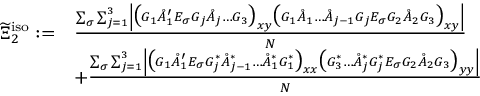Convert formula to latex. <formula><loc_0><loc_0><loc_500><loc_500>\begin{array} { r l } { \widetilde { \Xi } _ { 2 } ^ { i s o } \colon = } & { \frac { \sum _ { \sigma } \sum _ { j = 1 } ^ { 3 } \left | \left ( G _ { 1 } \mathring { A } _ { 1 } ^ { \prime } E _ { \sigma } G _ { j } \mathring { A } _ { j } \dots G _ { 3 } \right ) _ { x y } \left ( G _ { 1 } \mathring { A } _ { 1 } \dots \mathring { A } _ { j - 1 } G _ { j } E _ { \sigma } G _ { 2 } \mathring { A } _ { 2 } G _ { 3 } \right ) _ { x y } \right | } { N } } \\ & { + \frac { \sum _ { \sigma } \sum _ { j = 1 } ^ { 3 } \left | \left ( G _ { 1 } \mathring { A } _ { 1 } ^ { \prime } E _ { \sigma } G _ { j } ^ { * } \mathring { A } _ { j - 1 } ^ { * } \dots \mathring { A } _ { 1 } ^ { * } G _ { 1 } ^ { * } \right ) _ { x x } \left ( G _ { 3 } ^ { * } \dots \mathring { A } _ { j } ^ { * } G _ { j } ^ { * } E _ { \sigma } G _ { 2 } \mathring { A } _ { 2 } G _ { 3 } \right ) _ { y y } \right | } { N } } \end{array}</formula> 